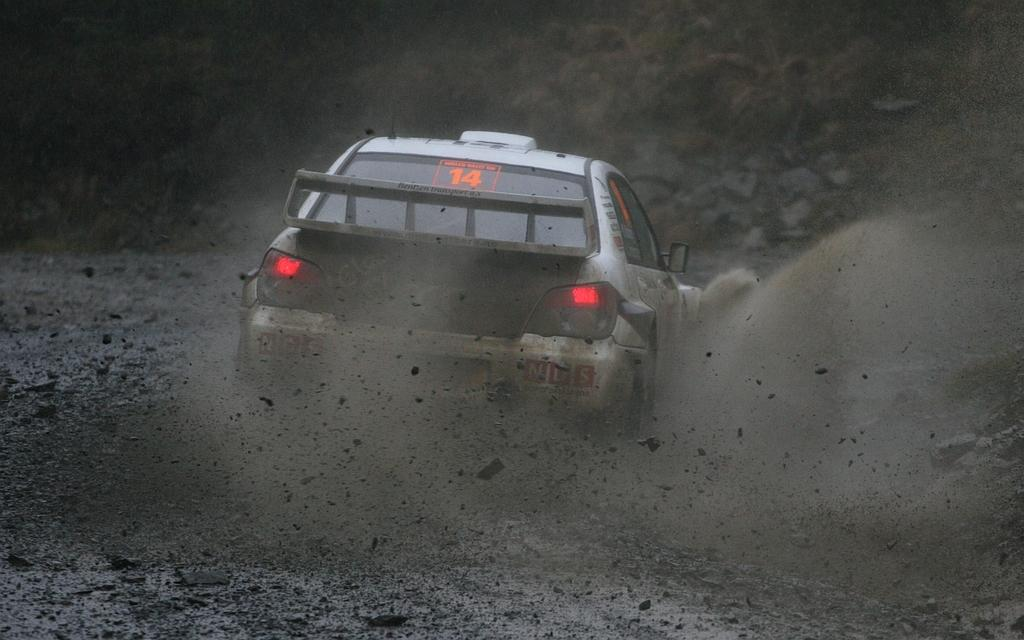What is the main subject in the center of the image? There is a passing car in the center of the image. What can be observed about the car's lights? The car's tail lights are on. What type of natural elements can be seen in the background of the image? There are rocks visible in the background of the image. What type of substance is present at the bottom of the image? Dust is present at the bottom of the image. What type of thread is being used to hold the banana in the image? There is no banana or thread present in the image. How does the car shake while passing in the image? The car does not shake while passing in the image; it is a still image. 